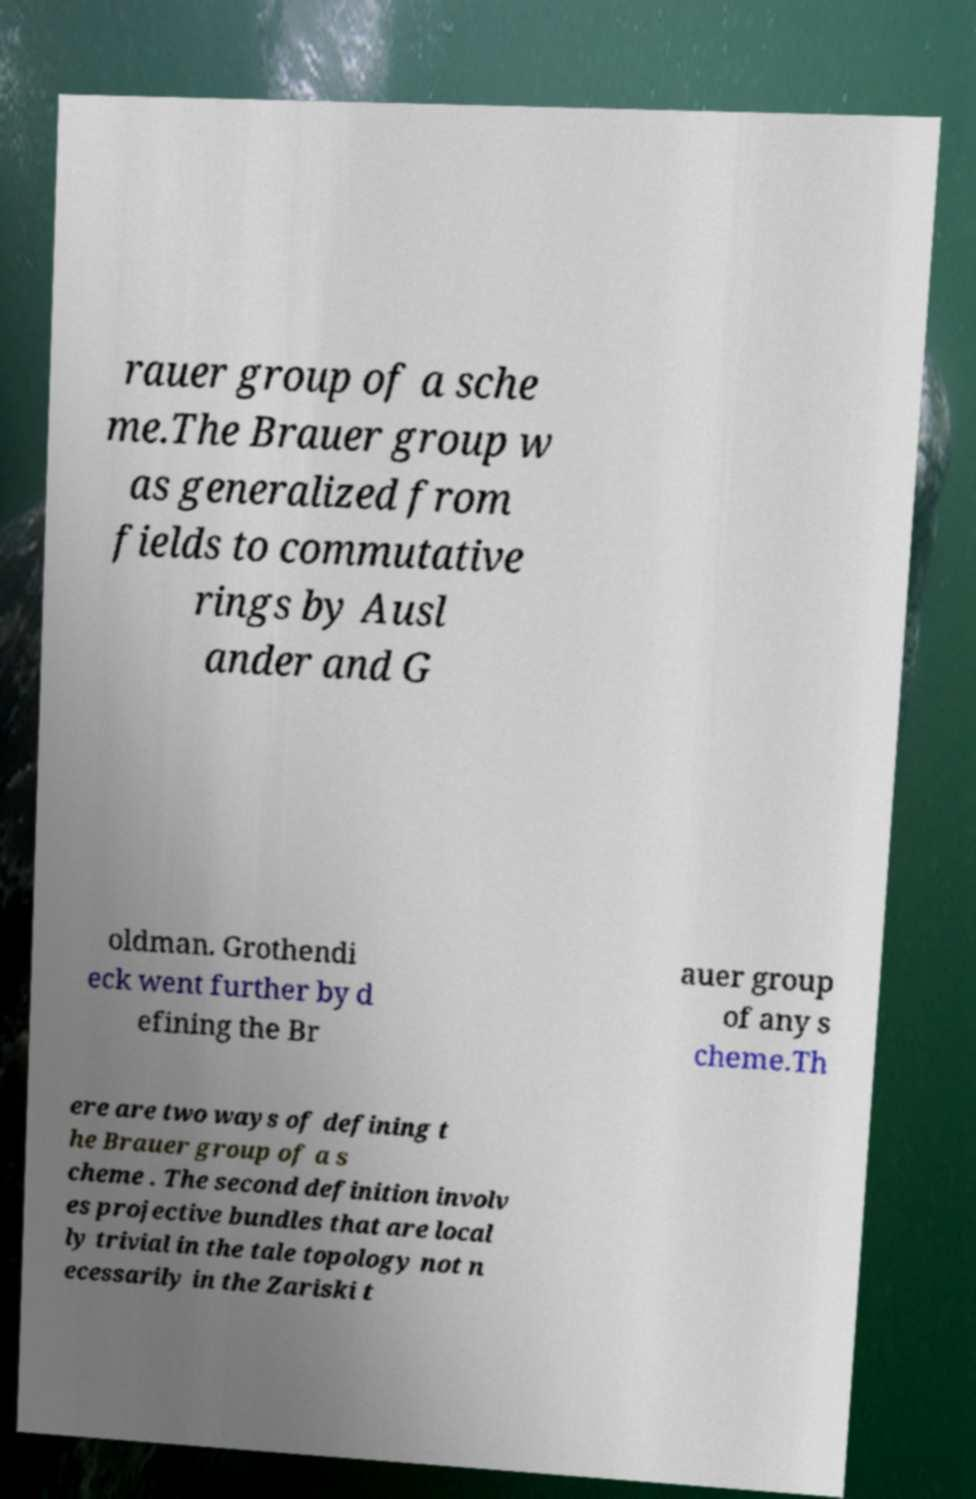Please read and relay the text visible in this image. What does it say? rauer group of a sche me.The Brauer group w as generalized from fields to commutative rings by Ausl ander and G oldman. Grothendi eck went further by d efining the Br auer group of any s cheme.Th ere are two ways of defining t he Brauer group of a s cheme . The second definition involv es projective bundles that are local ly trivial in the tale topology not n ecessarily in the Zariski t 